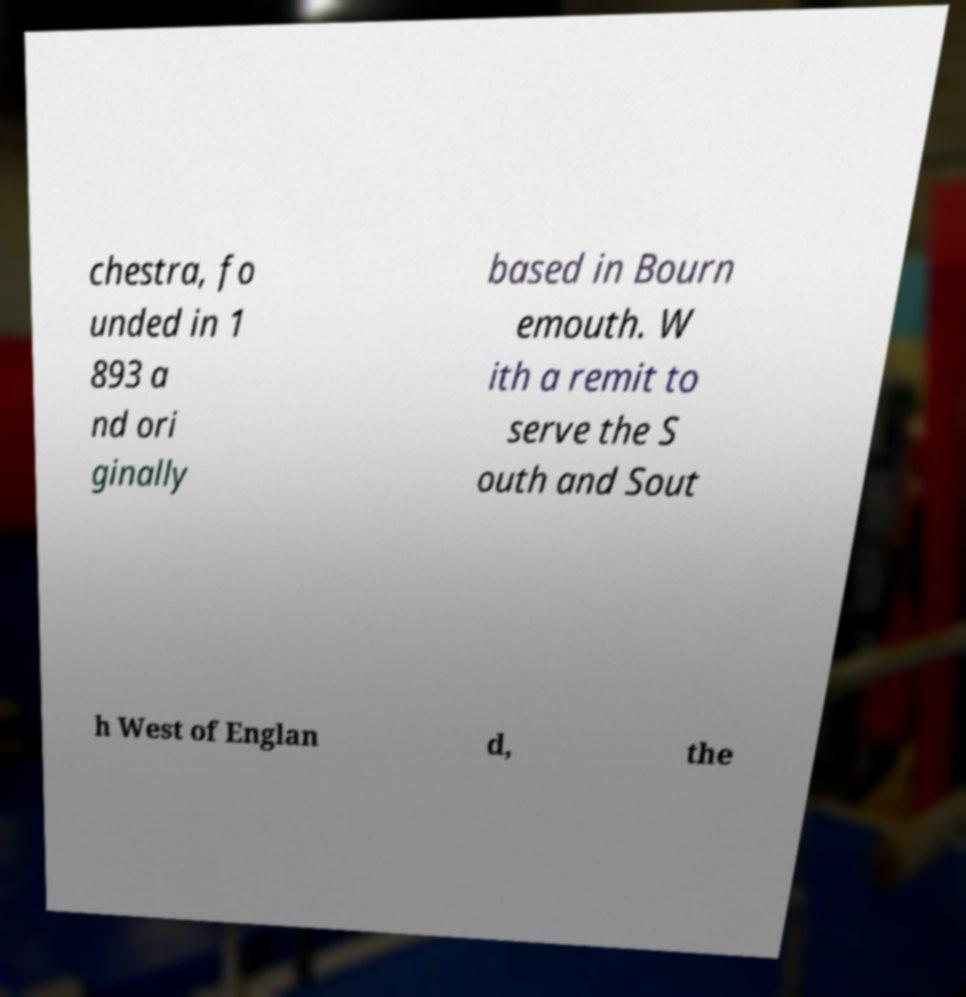For documentation purposes, I need the text within this image transcribed. Could you provide that? chestra, fo unded in 1 893 a nd ori ginally based in Bourn emouth. W ith a remit to serve the S outh and Sout h West of Englan d, the 